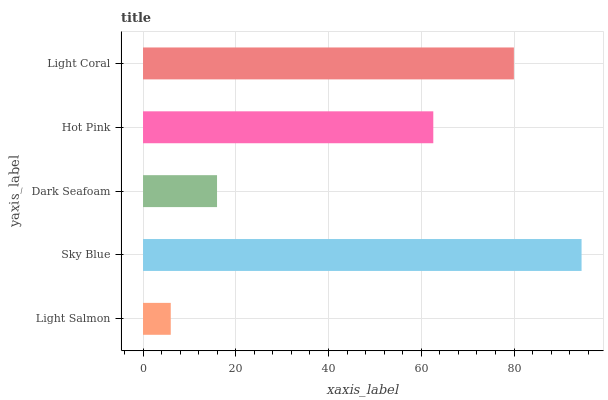Is Light Salmon the minimum?
Answer yes or no. Yes. Is Sky Blue the maximum?
Answer yes or no. Yes. Is Dark Seafoam the minimum?
Answer yes or no. No. Is Dark Seafoam the maximum?
Answer yes or no. No. Is Sky Blue greater than Dark Seafoam?
Answer yes or no. Yes. Is Dark Seafoam less than Sky Blue?
Answer yes or no. Yes. Is Dark Seafoam greater than Sky Blue?
Answer yes or no. No. Is Sky Blue less than Dark Seafoam?
Answer yes or no. No. Is Hot Pink the high median?
Answer yes or no. Yes. Is Hot Pink the low median?
Answer yes or no. Yes. Is Dark Seafoam the high median?
Answer yes or no. No. Is Sky Blue the low median?
Answer yes or no. No. 